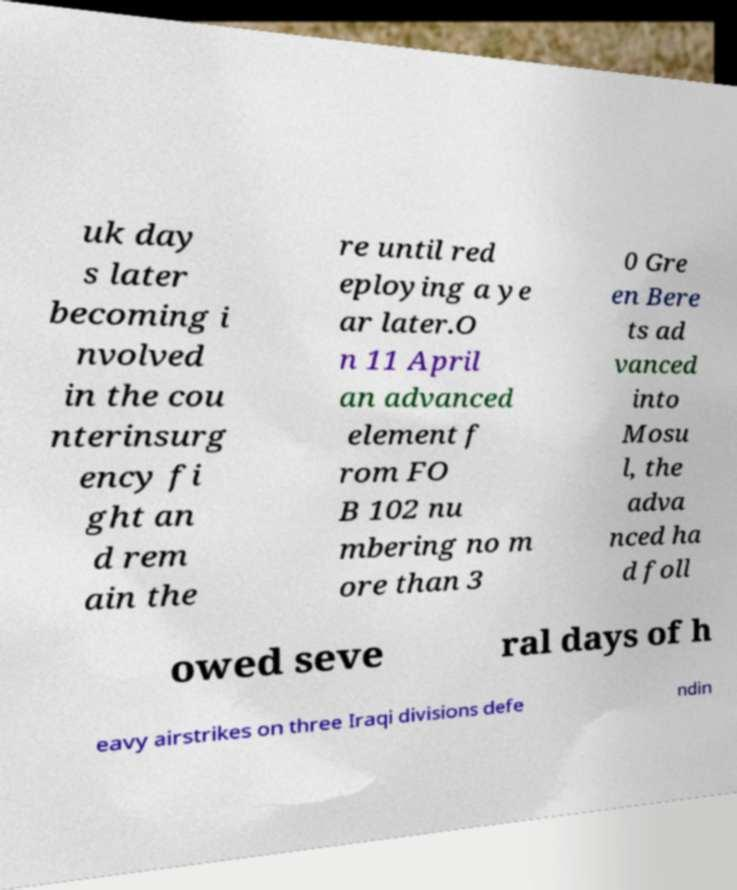Could you extract and type out the text from this image? uk day s later becoming i nvolved in the cou nterinsurg ency fi ght an d rem ain the re until red eploying a ye ar later.O n 11 April an advanced element f rom FO B 102 nu mbering no m ore than 3 0 Gre en Bere ts ad vanced into Mosu l, the adva nced ha d foll owed seve ral days of h eavy airstrikes on three Iraqi divisions defe ndin 